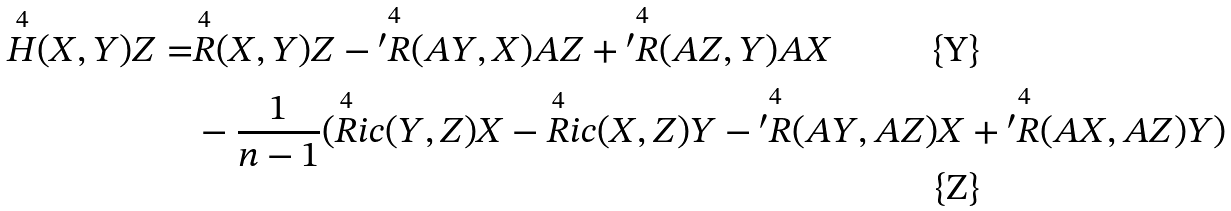<formula> <loc_0><loc_0><loc_500><loc_500>\overset { 4 } { H } ( X , Y ) Z = & \overset { 4 } { R } ( X , Y ) Z - \overset { 4 } { ^ { \prime } R } ( A Y , X ) A Z + \overset { 4 } { ^ { \prime } R } ( A Z , Y ) A X \\ & - \frac { 1 } { n - 1 } ( \overset { 4 } { R } i c ( Y , Z ) X - \overset { 4 } { R } i c ( X , Z ) Y - \overset { 4 } { ^ { \prime } R } ( A Y , A Z ) X + \overset { 4 } { ^ { \prime } R } ( A X , A Z ) Y )</formula> 